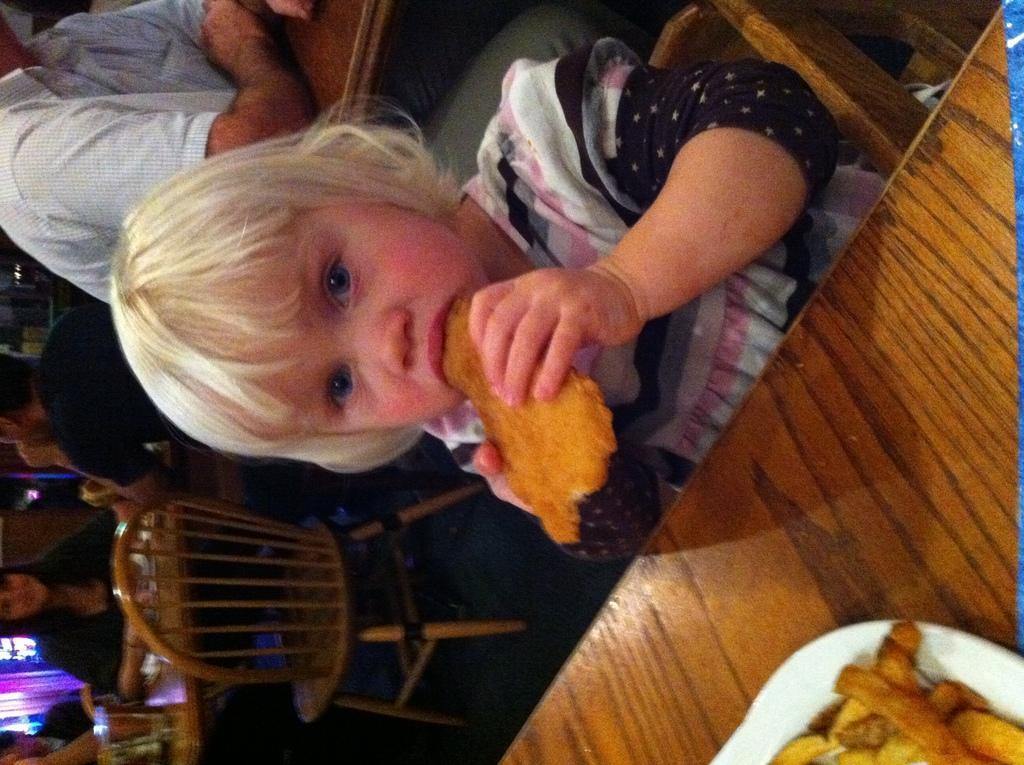How would you summarize this image in a sentence or two? There is a kid sitting on the chair and she is eating food. This is a table. On the table there is a plate and food. In the background we can see few people, chairs, and tables. 